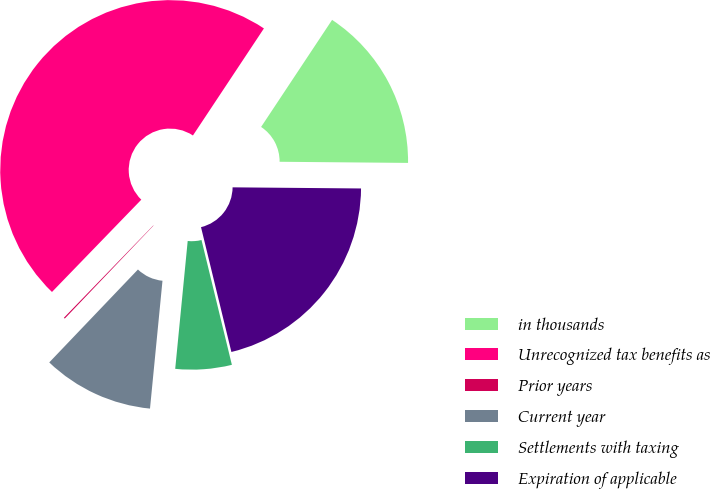Convert chart to OTSL. <chart><loc_0><loc_0><loc_500><loc_500><pie_chart><fcel>in thousands<fcel>Unrecognized tax benefits as<fcel>Prior years<fcel>Current year<fcel>Settlements with taxing<fcel>Expiration of applicable<nl><fcel>15.82%<fcel>47.08%<fcel>0.11%<fcel>10.58%<fcel>5.35%<fcel>21.06%<nl></chart> 